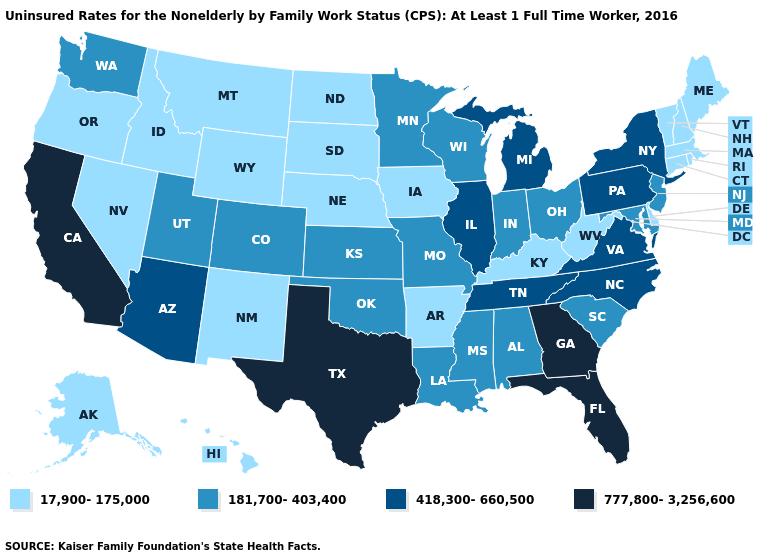Which states have the lowest value in the USA?
Be succinct. Alaska, Arkansas, Connecticut, Delaware, Hawaii, Idaho, Iowa, Kentucky, Maine, Massachusetts, Montana, Nebraska, Nevada, New Hampshire, New Mexico, North Dakota, Oregon, Rhode Island, South Dakota, Vermont, West Virginia, Wyoming. Name the states that have a value in the range 17,900-175,000?
Give a very brief answer. Alaska, Arkansas, Connecticut, Delaware, Hawaii, Idaho, Iowa, Kentucky, Maine, Massachusetts, Montana, Nebraska, Nevada, New Hampshire, New Mexico, North Dakota, Oregon, Rhode Island, South Dakota, Vermont, West Virginia, Wyoming. Name the states that have a value in the range 181,700-403,400?
Concise answer only. Alabama, Colorado, Indiana, Kansas, Louisiana, Maryland, Minnesota, Mississippi, Missouri, New Jersey, Ohio, Oklahoma, South Carolina, Utah, Washington, Wisconsin. What is the highest value in the MidWest ?
Answer briefly. 418,300-660,500. Does the first symbol in the legend represent the smallest category?
Be succinct. Yes. Does Indiana have the lowest value in the MidWest?
Give a very brief answer. No. Does the first symbol in the legend represent the smallest category?
Give a very brief answer. Yes. What is the lowest value in the Northeast?
Give a very brief answer. 17,900-175,000. Name the states that have a value in the range 181,700-403,400?
Answer briefly. Alabama, Colorado, Indiana, Kansas, Louisiana, Maryland, Minnesota, Mississippi, Missouri, New Jersey, Ohio, Oklahoma, South Carolina, Utah, Washington, Wisconsin. Name the states that have a value in the range 181,700-403,400?
Answer briefly. Alabama, Colorado, Indiana, Kansas, Louisiana, Maryland, Minnesota, Mississippi, Missouri, New Jersey, Ohio, Oklahoma, South Carolina, Utah, Washington, Wisconsin. What is the value of Maryland?
Answer briefly. 181,700-403,400. Name the states that have a value in the range 418,300-660,500?
Answer briefly. Arizona, Illinois, Michigan, New York, North Carolina, Pennsylvania, Tennessee, Virginia. Name the states that have a value in the range 17,900-175,000?
Concise answer only. Alaska, Arkansas, Connecticut, Delaware, Hawaii, Idaho, Iowa, Kentucky, Maine, Massachusetts, Montana, Nebraska, Nevada, New Hampshire, New Mexico, North Dakota, Oregon, Rhode Island, South Dakota, Vermont, West Virginia, Wyoming. Does the map have missing data?
Answer briefly. No. Which states have the highest value in the USA?
Keep it brief. California, Florida, Georgia, Texas. 